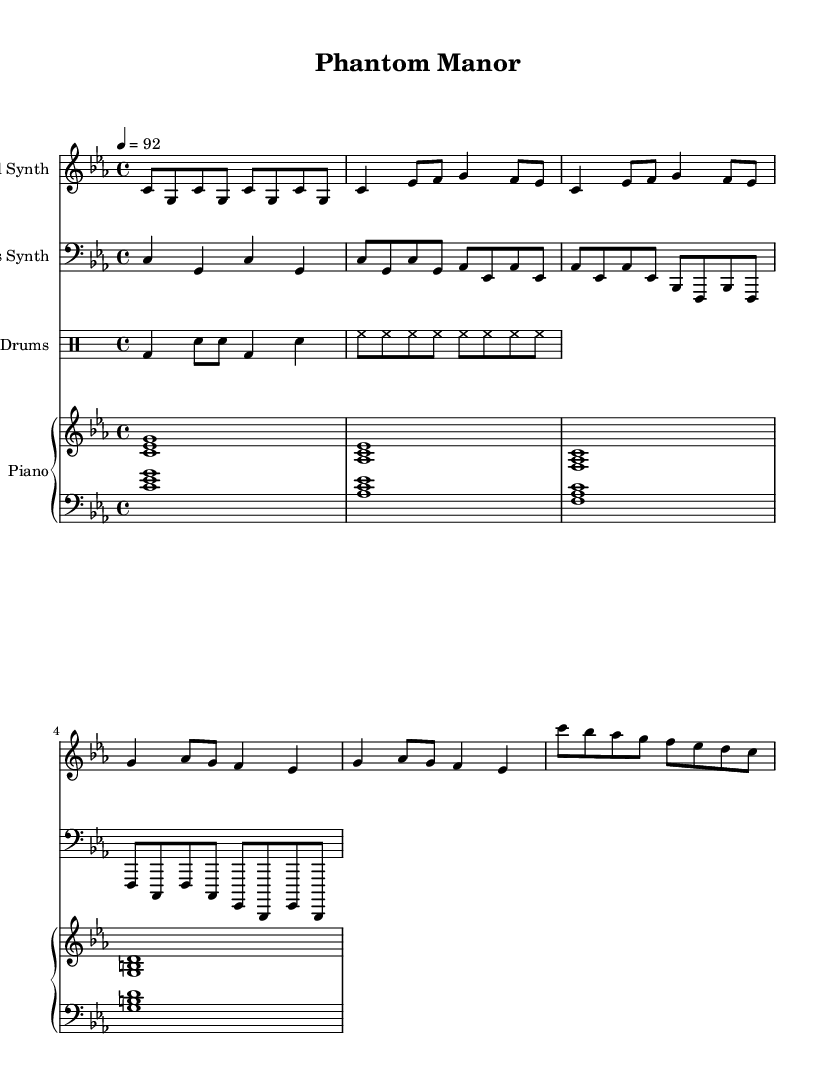What is the key signature of this music? The key signature is C minor, indicated by the presence of three flats in the music notation.
Answer: C minor What is the time signature of this piece? The time signature is 4/4, which means there are four beats in each measure and the quarter note receives one beat, as shown in the notation.
Answer: 4/4 What is the tempo marking for this piece? The tempo marking is 92 beats per minute, which is indicated in the score.
Answer: 92 How many measures are in the verse section? The verse section consists of two repeated measures, each containing four beats, totaling four measures indicated in the notation.
Answer: 4 Which instrument plays the lead synth part? The lead synth part is notated in the treble clef and labeled as "Lead Synth" at the beginning of its staff.
Answer: Lead Synth What is the rhythmic pattern for the drums? The drum part includes a bass drum followed by snare hits and hi-hat patterns, making it characteristic of Hip Hop beats.
Answer: Simplified hip hop pattern What is the relationship between the chorus and the verse in this piece? The chorus has a different melody and is notated separately, each section reinforcing the theme, which is common in Hip Hop music.
Answer: Different melody 